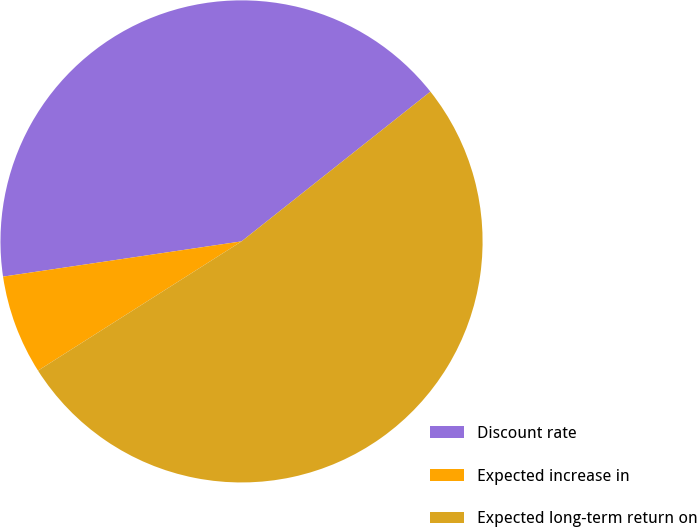Convert chart to OTSL. <chart><loc_0><loc_0><loc_500><loc_500><pie_chart><fcel>Discount rate<fcel>Expected increase in<fcel>Expected long-term return on<nl><fcel>41.67%<fcel>6.67%<fcel>51.67%<nl></chart> 